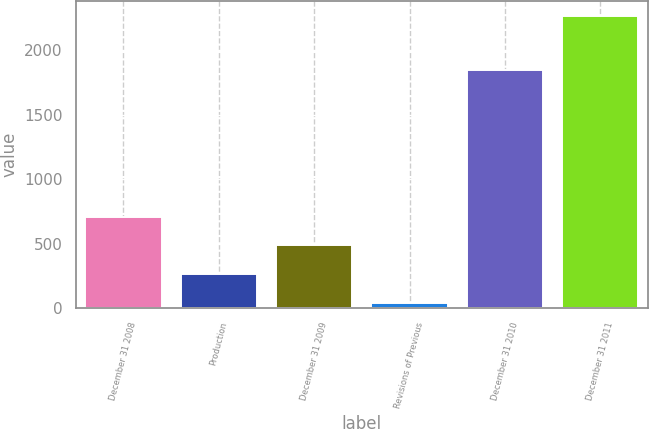<chart> <loc_0><loc_0><loc_500><loc_500><bar_chart><fcel>December 31 2008<fcel>Production<fcel>December 31 2009<fcel>Revisions of Previous<fcel>December 31 2010<fcel>December 31 2011<nl><fcel>709.4<fcel>263.8<fcel>486.6<fcel>41<fcel>1844<fcel>2269<nl></chart> 